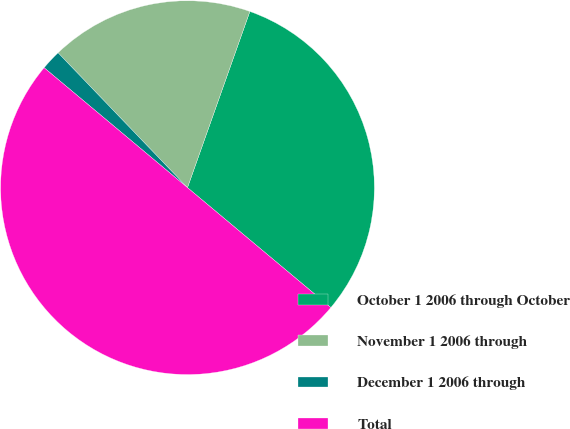<chart> <loc_0><loc_0><loc_500><loc_500><pie_chart><fcel>October 1 2006 through October<fcel>November 1 2006 through<fcel>December 1 2006 through<fcel>Total<nl><fcel>30.67%<fcel>17.59%<fcel>1.74%<fcel>50.0%<nl></chart> 